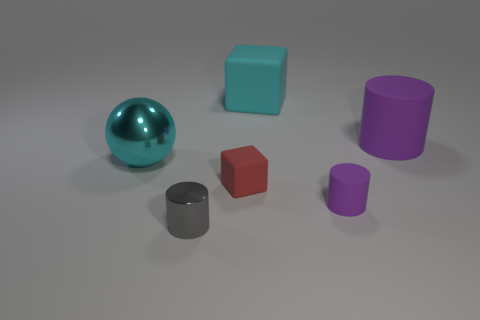There is a tiny gray object that is made of the same material as the cyan ball; what is its shape?
Offer a terse response. Cylinder. Are the tiny cylinder to the left of the big matte cube and the tiny purple thing made of the same material?
Keep it short and to the point. No. How many other objects are there of the same material as the big purple cylinder?
Provide a succinct answer. 3. What number of things are either matte cubes that are behind the red rubber thing or rubber objects on the right side of the cyan rubber block?
Give a very brief answer. 3. Do the big rubber thing on the right side of the small rubber cylinder and the shiny thing that is to the left of the small shiny object have the same shape?
Make the answer very short. No. What shape is the red object that is the same size as the gray thing?
Your answer should be very brief. Cube. How many metal objects are either large cyan spheres or cylinders?
Make the answer very short. 2. Is the big thing that is to the left of the tiny red matte object made of the same material as the large cyan object that is behind the big purple cylinder?
Provide a succinct answer. No. What is the color of the small object that is the same material as the small block?
Offer a very short reply. Purple. Is the number of big rubber cylinders behind the cyan metallic ball greater than the number of purple things in front of the small rubber cylinder?
Your answer should be compact. Yes. 